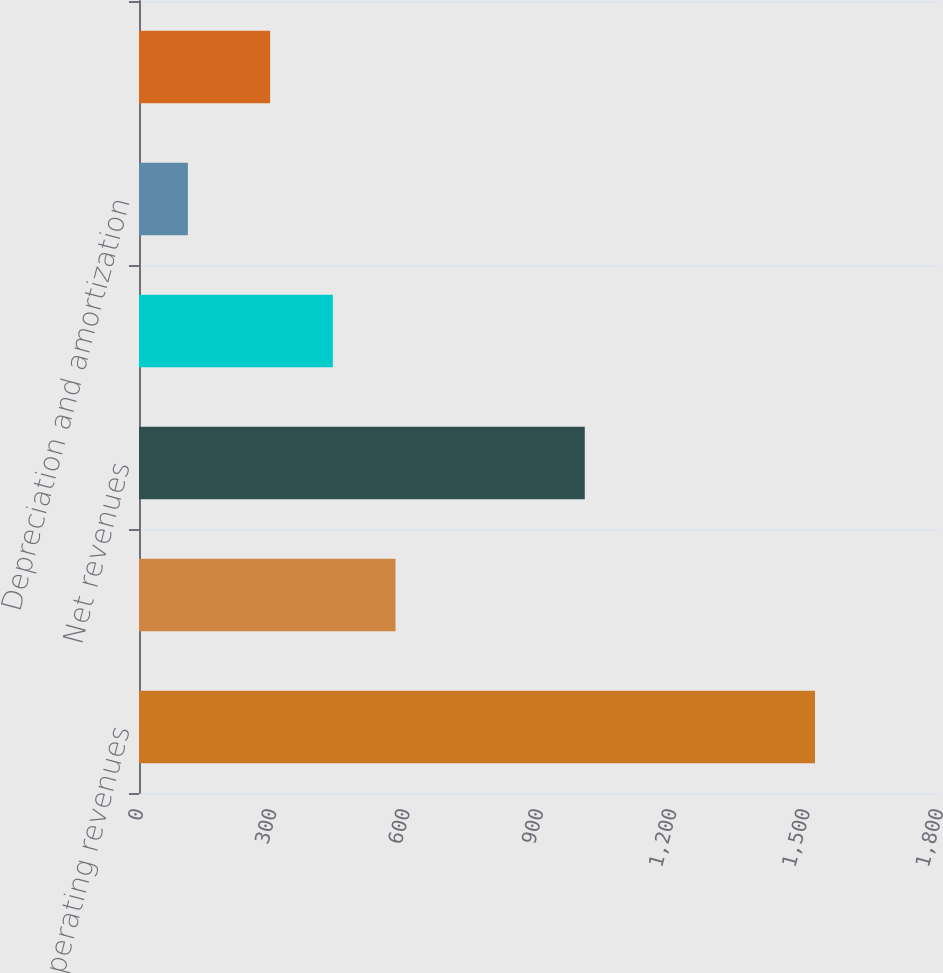Convert chart to OTSL. <chart><loc_0><loc_0><loc_500><loc_500><bar_chart><fcel>Operating revenues<fcel>Gas purchased for resale<fcel>Net revenues<fcel>Operations and maintenance<fcel>Depreciation and amortization<fcel>Gas operating income<nl><fcel>1521<fcel>577.2<fcel>1003<fcel>436.1<fcel>110<fcel>295<nl></chart> 